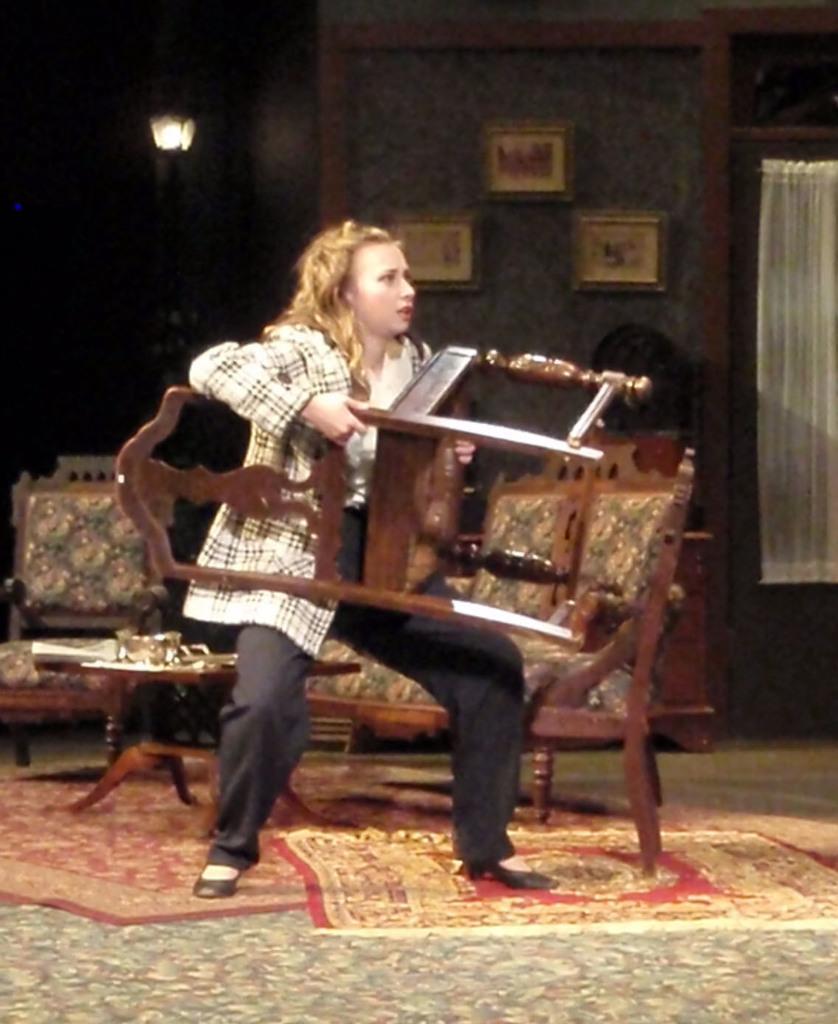In one or two sentences, can you explain what this image depicts? In this picture we can observe a woman wearing a white color shirt and holding a brown color chair in her hands. Behind her there is a table and some chairs which were in brown color. We can observe a carpet on the floor. In the background there are some photo frames fixed to the wall. We can observe white color curtain and a lamp here. 